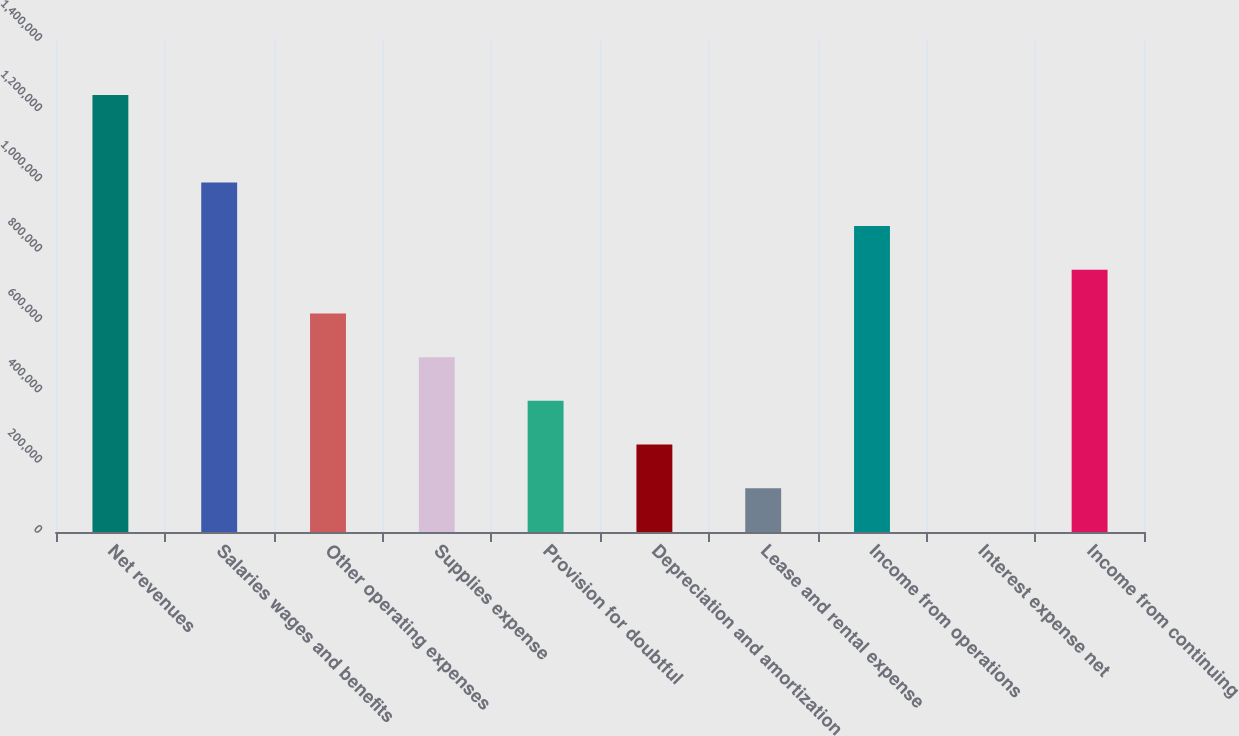<chart> <loc_0><loc_0><loc_500><loc_500><bar_chart><fcel>Net revenues<fcel>Salaries wages and benefits<fcel>Other operating expenses<fcel>Supplies expense<fcel>Provision for doubtful<fcel>Depreciation and amortization<fcel>Lease and rental expense<fcel>Income from operations<fcel>Interest expense net<fcel>Income from continuing<nl><fcel>1.24345e+06<fcel>994807<fcel>621836<fcel>497512<fcel>373189<fcel>248865<fcel>124542<fcel>870483<fcel>218<fcel>746160<nl></chart> 